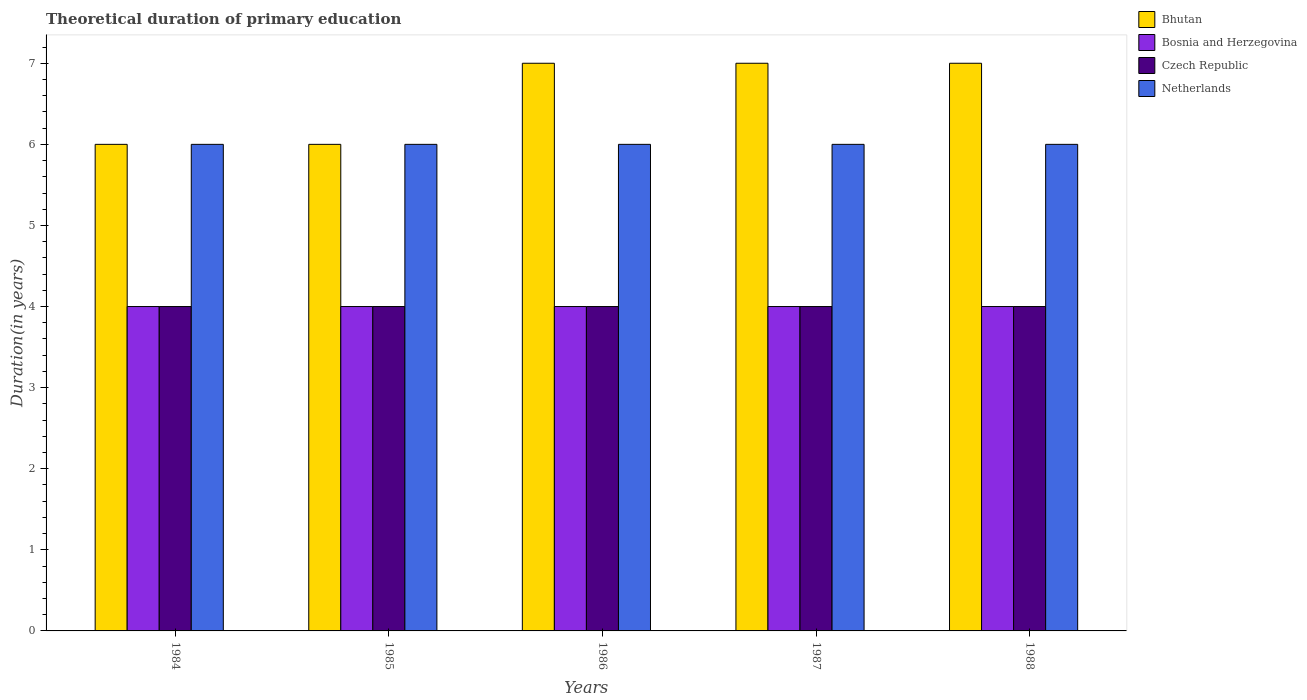Are the number of bars per tick equal to the number of legend labels?
Keep it short and to the point. Yes. How many bars are there on the 1st tick from the left?
Ensure brevity in your answer.  4. What is the label of the 1st group of bars from the left?
Make the answer very short. 1984. What is the total theoretical duration of primary education in Bosnia and Herzegovina in 1987?
Offer a very short reply. 4. Across all years, what is the maximum total theoretical duration of primary education in Netherlands?
Your answer should be very brief. 6. In which year was the total theoretical duration of primary education in Netherlands maximum?
Keep it short and to the point. 1984. In which year was the total theoretical duration of primary education in Czech Republic minimum?
Give a very brief answer. 1984. What is the total total theoretical duration of primary education in Czech Republic in the graph?
Provide a succinct answer. 20. What is the difference between the total theoretical duration of primary education in Bhutan in 1986 and the total theoretical duration of primary education in Netherlands in 1985?
Provide a short and direct response. 1. In the year 1987, what is the difference between the total theoretical duration of primary education in Netherlands and total theoretical duration of primary education in Bhutan?
Your response must be concise. -1. In how many years, is the total theoretical duration of primary education in Bhutan greater than 5.8 years?
Your response must be concise. 5. What is the ratio of the total theoretical duration of primary education in Bhutan in 1985 to that in 1986?
Keep it short and to the point. 0.86. Is the total theoretical duration of primary education in Bosnia and Herzegovina in 1985 less than that in 1988?
Make the answer very short. No. Is the difference between the total theoretical duration of primary education in Netherlands in 1986 and 1987 greater than the difference between the total theoretical duration of primary education in Bhutan in 1986 and 1987?
Give a very brief answer. No. What is the difference between the highest and the lowest total theoretical duration of primary education in Czech Republic?
Your response must be concise. 0. In how many years, is the total theoretical duration of primary education in Netherlands greater than the average total theoretical duration of primary education in Netherlands taken over all years?
Make the answer very short. 0. Is the sum of the total theoretical duration of primary education in Bosnia and Herzegovina in 1987 and 1988 greater than the maximum total theoretical duration of primary education in Czech Republic across all years?
Make the answer very short. Yes. Is it the case that in every year, the sum of the total theoretical duration of primary education in Czech Republic and total theoretical duration of primary education in Bosnia and Herzegovina is greater than the sum of total theoretical duration of primary education in Bhutan and total theoretical duration of primary education in Netherlands?
Make the answer very short. No. What does the 4th bar from the left in 1988 represents?
Your answer should be very brief. Netherlands. What does the 4th bar from the right in 1988 represents?
Keep it short and to the point. Bhutan. Is it the case that in every year, the sum of the total theoretical duration of primary education in Bosnia and Herzegovina and total theoretical duration of primary education in Czech Republic is greater than the total theoretical duration of primary education in Bhutan?
Your answer should be very brief. Yes. How many bars are there?
Give a very brief answer. 20. How many years are there in the graph?
Your response must be concise. 5. Does the graph contain any zero values?
Make the answer very short. No. How many legend labels are there?
Your answer should be very brief. 4. What is the title of the graph?
Offer a terse response. Theoretical duration of primary education. What is the label or title of the X-axis?
Offer a very short reply. Years. What is the label or title of the Y-axis?
Your answer should be compact. Duration(in years). What is the Duration(in years) of Bhutan in 1985?
Offer a terse response. 6. What is the Duration(in years) of Czech Republic in 1985?
Your answer should be very brief. 4. What is the Duration(in years) of Netherlands in 1985?
Your answer should be compact. 6. What is the Duration(in years) of Bosnia and Herzegovina in 1986?
Offer a terse response. 4. What is the Duration(in years) of Czech Republic in 1986?
Your answer should be compact. 4. What is the Duration(in years) of Netherlands in 1986?
Provide a succinct answer. 6. What is the Duration(in years) of Netherlands in 1987?
Give a very brief answer. 6. What is the Duration(in years) of Bhutan in 1988?
Offer a very short reply. 7. What is the Duration(in years) of Czech Republic in 1988?
Give a very brief answer. 4. Across all years, what is the maximum Duration(in years) of Bhutan?
Ensure brevity in your answer.  7. Across all years, what is the maximum Duration(in years) of Bosnia and Herzegovina?
Provide a succinct answer. 4. Across all years, what is the maximum Duration(in years) of Czech Republic?
Make the answer very short. 4. Across all years, what is the maximum Duration(in years) in Netherlands?
Make the answer very short. 6. Across all years, what is the minimum Duration(in years) of Czech Republic?
Offer a terse response. 4. Across all years, what is the minimum Duration(in years) in Netherlands?
Ensure brevity in your answer.  6. What is the total Duration(in years) of Bhutan in the graph?
Ensure brevity in your answer.  33. What is the total Duration(in years) in Netherlands in the graph?
Keep it short and to the point. 30. What is the difference between the Duration(in years) of Bhutan in 1984 and that in 1985?
Your response must be concise. 0. What is the difference between the Duration(in years) of Netherlands in 1984 and that in 1985?
Your answer should be very brief. 0. What is the difference between the Duration(in years) in Czech Republic in 1984 and that in 1986?
Give a very brief answer. 0. What is the difference between the Duration(in years) in Netherlands in 1984 and that in 1986?
Your answer should be compact. 0. What is the difference between the Duration(in years) of Czech Republic in 1984 and that in 1987?
Your response must be concise. 0. What is the difference between the Duration(in years) in Bosnia and Herzegovina in 1984 and that in 1988?
Provide a succinct answer. 0. What is the difference between the Duration(in years) in Czech Republic in 1984 and that in 1988?
Ensure brevity in your answer.  0. What is the difference between the Duration(in years) of Netherlands in 1984 and that in 1988?
Offer a very short reply. 0. What is the difference between the Duration(in years) in Czech Republic in 1985 and that in 1986?
Your answer should be compact. 0. What is the difference between the Duration(in years) in Czech Republic in 1985 and that in 1987?
Give a very brief answer. 0. What is the difference between the Duration(in years) in Netherlands in 1985 and that in 1987?
Provide a short and direct response. 0. What is the difference between the Duration(in years) in Bhutan in 1985 and that in 1988?
Offer a very short reply. -1. What is the difference between the Duration(in years) of Netherlands in 1985 and that in 1988?
Your answer should be compact. 0. What is the difference between the Duration(in years) in Bosnia and Herzegovina in 1986 and that in 1988?
Provide a succinct answer. 0. What is the difference between the Duration(in years) of Czech Republic in 1986 and that in 1988?
Make the answer very short. 0. What is the difference between the Duration(in years) of Netherlands in 1986 and that in 1988?
Provide a succinct answer. 0. What is the difference between the Duration(in years) in Bhutan in 1987 and that in 1988?
Provide a short and direct response. 0. What is the difference between the Duration(in years) of Bosnia and Herzegovina in 1987 and that in 1988?
Your answer should be compact. 0. What is the difference between the Duration(in years) in Netherlands in 1987 and that in 1988?
Your answer should be compact. 0. What is the difference between the Duration(in years) of Bhutan in 1984 and the Duration(in years) of Bosnia and Herzegovina in 1985?
Offer a very short reply. 2. What is the difference between the Duration(in years) in Bhutan in 1984 and the Duration(in years) in Czech Republic in 1985?
Provide a succinct answer. 2. What is the difference between the Duration(in years) in Czech Republic in 1984 and the Duration(in years) in Netherlands in 1985?
Provide a short and direct response. -2. What is the difference between the Duration(in years) of Bosnia and Herzegovina in 1984 and the Duration(in years) of Czech Republic in 1986?
Make the answer very short. 0. What is the difference between the Duration(in years) in Bhutan in 1984 and the Duration(in years) in Bosnia and Herzegovina in 1987?
Your answer should be compact. 2. What is the difference between the Duration(in years) in Bhutan in 1984 and the Duration(in years) in Czech Republic in 1987?
Your answer should be compact. 2. What is the difference between the Duration(in years) of Bosnia and Herzegovina in 1984 and the Duration(in years) of Netherlands in 1987?
Provide a short and direct response. -2. What is the difference between the Duration(in years) of Bhutan in 1984 and the Duration(in years) of Bosnia and Herzegovina in 1988?
Offer a very short reply. 2. What is the difference between the Duration(in years) in Bhutan in 1984 and the Duration(in years) in Czech Republic in 1988?
Offer a terse response. 2. What is the difference between the Duration(in years) of Bosnia and Herzegovina in 1984 and the Duration(in years) of Czech Republic in 1988?
Your answer should be compact. 0. What is the difference between the Duration(in years) in Bosnia and Herzegovina in 1984 and the Duration(in years) in Netherlands in 1988?
Offer a very short reply. -2. What is the difference between the Duration(in years) of Bhutan in 1985 and the Duration(in years) of Netherlands in 1986?
Your answer should be very brief. 0. What is the difference between the Duration(in years) of Bosnia and Herzegovina in 1985 and the Duration(in years) of Czech Republic in 1986?
Your answer should be compact. 0. What is the difference between the Duration(in years) in Bosnia and Herzegovina in 1985 and the Duration(in years) in Netherlands in 1986?
Your response must be concise. -2. What is the difference between the Duration(in years) in Bhutan in 1985 and the Duration(in years) in Bosnia and Herzegovina in 1987?
Your response must be concise. 2. What is the difference between the Duration(in years) in Bhutan in 1985 and the Duration(in years) in Netherlands in 1987?
Keep it short and to the point. 0. What is the difference between the Duration(in years) of Bosnia and Herzegovina in 1985 and the Duration(in years) of Czech Republic in 1987?
Offer a terse response. 0. What is the difference between the Duration(in years) in Bosnia and Herzegovina in 1985 and the Duration(in years) in Netherlands in 1987?
Offer a terse response. -2. What is the difference between the Duration(in years) in Czech Republic in 1985 and the Duration(in years) in Netherlands in 1987?
Provide a succinct answer. -2. What is the difference between the Duration(in years) of Bhutan in 1985 and the Duration(in years) of Netherlands in 1988?
Your response must be concise. 0. What is the difference between the Duration(in years) in Czech Republic in 1985 and the Duration(in years) in Netherlands in 1988?
Give a very brief answer. -2. What is the difference between the Duration(in years) of Bhutan in 1986 and the Duration(in years) of Netherlands in 1987?
Provide a succinct answer. 1. What is the difference between the Duration(in years) in Bosnia and Herzegovina in 1986 and the Duration(in years) in Czech Republic in 1987?
Make the answer very short. 0. What is the difference between the Duration(in years) of Bosnia and Herzegovina in 1986 and the Duration(in years) of Netherlands in 1987?
Your answer should be very brief. -2. What is the difference between the Duration(in years) in Czech Republic in 1986 and the Duration(in years) in Netherlands in 1987?
Make the answer very short. -2. What is the difference between the Duration(in years) in Bhutan in 1986 and the Duration(in years) in Bosnia and Herzegovina in 1988?
Provide a short and direct response. 3. What is the difference between the Duration(in years) of Bhutan in 1986 and the Duration(in years) of Czech Republic in 1988?
Keep it short and to the point. 3. What is the difference between the Duration(in years) in Bhutan in 1986 and the Duration(in years) in Netherlands in 1988?
Your response must be concise. 1. What is the difference between the Duration(in years) of Czech Republic in 1986 and the Duration(in years) of Netherlands in 1988?
Ensure brevity in your answer.  -2. What is the difference between the Duration(in years) of Bhutan in 1987 and the Duration(in years) of Bosnia and Herzegovina in 1988?
Your answer should be compact. 3. What is the difference between the Duration(in years) in Bhutan in 1987 and the Duration(in years) in Netherlands in 1988?
Offer a terse response. 1. What is the difference between the Duration(in years) of Czech Republic in 1987 and the Duration(in years) of Netherlands in 1988?
Keep it short and to the point. -2. What is the average Duration(in years) of Bhutan per year?
Your answer should be very brief. 6.6. What is the average Duration(in years) in Bosnia and Herzegovina per year?
Your answer should be compact. 4. What is the average Duration(in years) in Czech Republic per year?
Offer a very short reply. 4. What is the average Duration(in years) in Netherlands per year?
Provide a succinct answer. 6. In the year 1984, what is the difference between the Duration(in years) in Bhutan and Duration(in years) in Czech Republic?
Provide a short and direct response. 2. In the year 1984, what is the difference between the Duration(in years) of Bosnia and Herzegovina and Duration(in years) of Czech Republic?
Give a very brief answer. 0. In the year 1985, what is the difference between the Duration(in years) of Bhutan and Duration(in years) of Bosnia and Herzegovina?
Offer a terse response. 2. In the year 1985, what is the difference between the Duration(in years) of Bhutan and Duration(in years) of Netherlands?
Make the answer very short. 0. In the year 1985, what is the difference between the Duration(in years) in Bosnia and Herzegovina and Duration(in years) in Czech Republic?
Ensure brevity in your answer.  0. In the year 1985, what is the difference between the Duration(in years) of Bosnia and Herzegovina and Duration(in years) of Netherlands?
Make the answer very short. -2. In the year 1985, what is the difference between the Duration(in years) of Czech Republic and Duration(in years) of Netherlands?
Your answer should be very brief. -2. In the year 1986, what is the difference between the Duration(in years) of Bhutan and Duration(in years) of Bosnia and Herzegovina?
Your answer should be very brief. 3. In the year 1986, what is the difference between the Duration(in years) in Bhutan and Duration(in years) in Czech Republic?
Give a very brief answer. 3. In the year 1986, what is the difference between the Duration(in years) in Bosnia and Herzegovina and Duration(in years) in Czech Republic?
Your answer should be very brief. 0. In the year 1987, what is the difference between the Duration(in years) in Bhutan and Duration(in years) in Bosnia and Herzegovina?
Your answer should be compact. 3. In the year 1987, what is the difference between the Duration(in years) of Bosnia and Herzegovina and Duration(in years) of Czech Republic?
Ensure brevity in your answer.  0. In the year 1987, what is the difference between the Duration(in years) of Bosnia and Herzegovina and Duration(in years) of Netherlands?
Ensure brevity in your answer.  -2. In the year 1987, what is the difference between the Duration(in years) in Czech Republic and Duration(in years) in Netherlands?
Give a very brief answer. -2. In the year 1988, what is the difference between the Duration(in years) in Bhutan and Duration(in years) in Bosnia and Herzegovina?
Your answer should be compact. 3. In the year 1988, what is the difference between the Duration(in years) of Bosnia and Herzegovina and Duration(in years) of Netherlands?
Provide a succinct answer. -2. In the year 1988, what is the difference between the Duration(in years) of Czech Republic and Duration(in years) of Netherlands?
Keep it short and to the point. -2. What is the ratio of the Duration(in years) in Bhutan in 1984 to that in 1986?
Give a very brief answer. 0.86. What is the ratio of the Duration(in years) in Bosnia and Herzegovina in 1984 to that in 1986?
Your response must be concise. 1. What is the ratio of the Duration(in years) in Czech Republic in 1984 to that in 1986?
Provide a short and direct response. 1. What is the ratio of the Duration(in years) of Czech Republic in 1984 to that in 1987?
Keep it short and to the point. 1. What is the ratio of the Duration(in years) in Netherlands in 1984 to that in 1987?
Your answer should be very brief. 1. What is the ratio of the Duration(in years) in Bhutan in 1984 to that in 1988?
Ensure brevity in your answer.  0.86. What is the ratio of the Duration(in years) of Bosnia and Herzegovina in 1984 to that in 1988?
Provide a short and direct response. 1. What is the ratio of the Duration(in years) in Bosnia and Herzegovina in 1985 to that in 1986?
Your response must be concise. 1. What is the ratio of the Duration(in years) of Bosnia and Herzegovina in 1985 to that in 1987?
Make the answer very short. 1. What is the ratio of the Duration(in years) in Czech Republic in 1985 to that in 1987?
Your answer should be compact. 1. What is the ratio of the Duration(in years) of Bhutan in 1985 to that in 1988?
Provide a short and direct response. 0.86. What is the ratio of the Duration(in years) of Netherlands in 1985 to that in 1988?
Your answer should be compact. 1. What is the ratio of the Duration(in years) of Bhutan in 1986 to that in 1987?
Give a very brief answer. 1. What is the ratio of the Duration(in years) in Czech Republic in 1986 to that in 1987?
Offer a terse response. 1. What is the ratio of the Duration(in years) in Netherlands in 1986 to that in 1987?
Keep it short and to the point. 1. What is the ratio of the Duration(in years) in Bosnia and Herzegovina in 1986 to that in 1988?
Keep it short and to the point. 1. What is the ratio of the Duration(in years) of Czech Republic in 1986 to that in 1988?
Give a very brief answer. 1. What is the ratio of the Duration(in years) in Netherlands in 1986 to that in 1988?
Your answer should be very brief. 1. What is the ratio of the Duration(in years) of Bosnia and Herzegovina in 1987 to that in 1988?
Provide a short and direct response. 1. What is the ratio of the Duration(in years) of Czech Republic in 1987 to that in 1988?
Your answer should be compact. 1. What is the ratio of the Duration(in years) of Netherlands in 1987 to that in 1988?
Give a very brief answer. 1. What is the difference between the highest and the second highest Duration(in years) of Bhutan?
Your response must be concise. 0. What is the difference between the highest and the second highest Duration(in years) in Bosnia and Herzegovina?
Provide a short and direct response. 0. What is the difference between the highest and the second highest Duration(in years) in Czech Republic?
Make the answer very short. 0. What is the difference between the highest and the second highest Duration(in years) in Netherlands?
Provide a succinct answer. 0. What is the difference between the highest and the lowest Duration(in years) in Bhutan?
Offer a terse response. 1. What is the difference between the highest and the lowest Duration(in years) of Czech Republic?
Your answer should be compact. 0. What is the difference between the highest and the lowest Duration(in years) of Netherlands?
Your answer should be very brief. 0. 